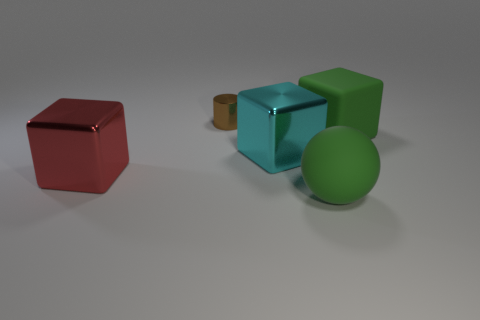Is the color of the big shiny object that is on the left side of the brown thing the same as the tiny thing?
Offer a very short reply. No. There is a shiny thing that is on the left side of the tiny brown cylinder; are there any small brown shiny cylinders to the right of it?
Offer a very short reply. Yes. There is a thing that is both behind the red object and in front of the green block; what material is it made of?
Keep it short and to the point. Metal. There is a cyan object that is made of the same material as the red object; what shape is it?
Your answer should be compact. Cube. Are there any other things that are the same shape as the tiny metal thing?
Your answer should be compact. No. Does the block left of the brown metallic cylinder have the same material as the small object?
Provide a succinct answer. Yes. What is the thing that is behind the green cube made of?
Give a very brief answer. Metal. What is the size of the shiny thing that is behind the metal object that is on the right side of the tiny cylinder?
Ensure brevity in your answer.  Small. How many brown cylinders are the same size as the cyan shiny block?
Provide a succinct answer. 0. Does the large matte object behind the large red cube have the same color as the rubber sphere to the right of the brown cylinder?
Ensure brevity in your answer.  Yes. 